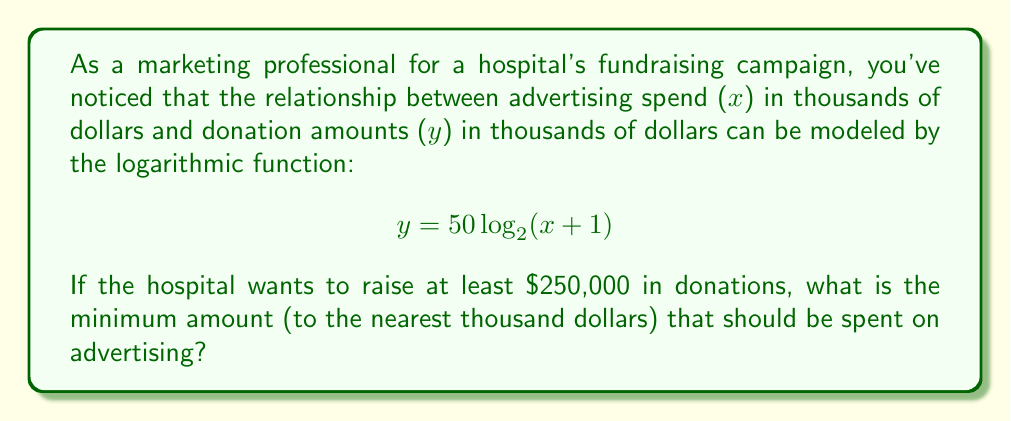Teach me how to tackle this problem. Let's approach this step-by-step:

1) We want to find x when y ≥ 250 (since y is in thousands of dollars).

2) Substitute this into our equation:
   $250 \leq 50 \log_2(x + 1)$

3) Divide both sides by 50:
   $5 \leq \log_2(x + 1)$

4) Apply $2^x$ to both sides to isolate (x + 1):
   $2^5 \leq x + 1$

5) Simplify:
   $32 \leq x + 1$

6) Subtract 1 from both sides:
   $31 \leq x$

7) Since x represents thousands of dollars and we need to round to the nearest thousand, our answer is 31.

This means we need to spend at least $31,000 on advertising to potentially raise $250,000 or more in donations.
Answer: $31,000 